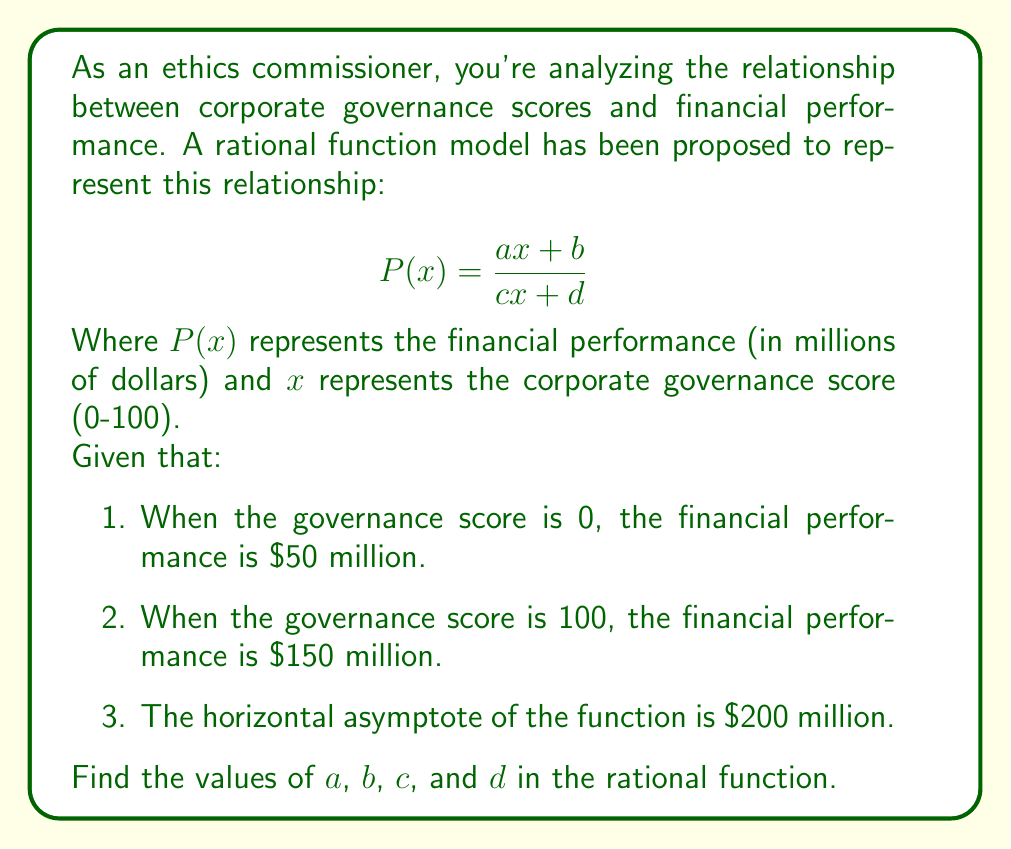Can you answer this question? Let's solve this step-by-step:

1) First, we use the horizontal asymptote information:
   The horizontal asymptote of a rational function $\frac{ax+b}{cx+d}$ is $\frac{a}{c}$ as $x$ approaches infinity.
   So, $\frac{a}{c} = 200$

2) Now, let's use the given points:
   When $x = 0$, $P(0) = 50$:
   $$\frac{b}{d} = 50$$

   When $x = 100$, $P(100) = 150$:
   $$\frac{100a + b}{100c + d} = 150$$

3) From step 1, we can say $a = 200c$. Let's substitute this into the equation from step 2:
   $$\frac{20000c + b}{100c + d} = 150$$

4) Now we have a system of three equations:
   $\frac{b}{d} = 50$
   $\frac{20000c + b}{100c + d} = 150$
   $a = 200c$

5) From $\frac{b}{d} = 50$, we can say $b = 50d$

6) Substituting this into the second equation:
   $$\frac{20000c + 50d}{100c + d} = 150$$

7) Cross-multiplying:
   $20000c + 50d = 15000c + 150d$
   $5000c = 100d$
   $c = \frac{d}{50}$

8) Substituting back into $a = 200c$:
   $a = 200 \cdot \frac{d}{50} = 4d$

9) We can choose any value for $d$. Let's choose $d = 1$ for simplicity.
   Then: $c = \frac{1}{50}$, $a = 4$, and $b = 50$

Therefore, the rational function is:
$$P(x) = \frac{4x + 50}{\frac{1}{50}x + 1}$$
Answer: $a=4$, $b=50$, $c=\frac{1}{50}$, $d=1$ 